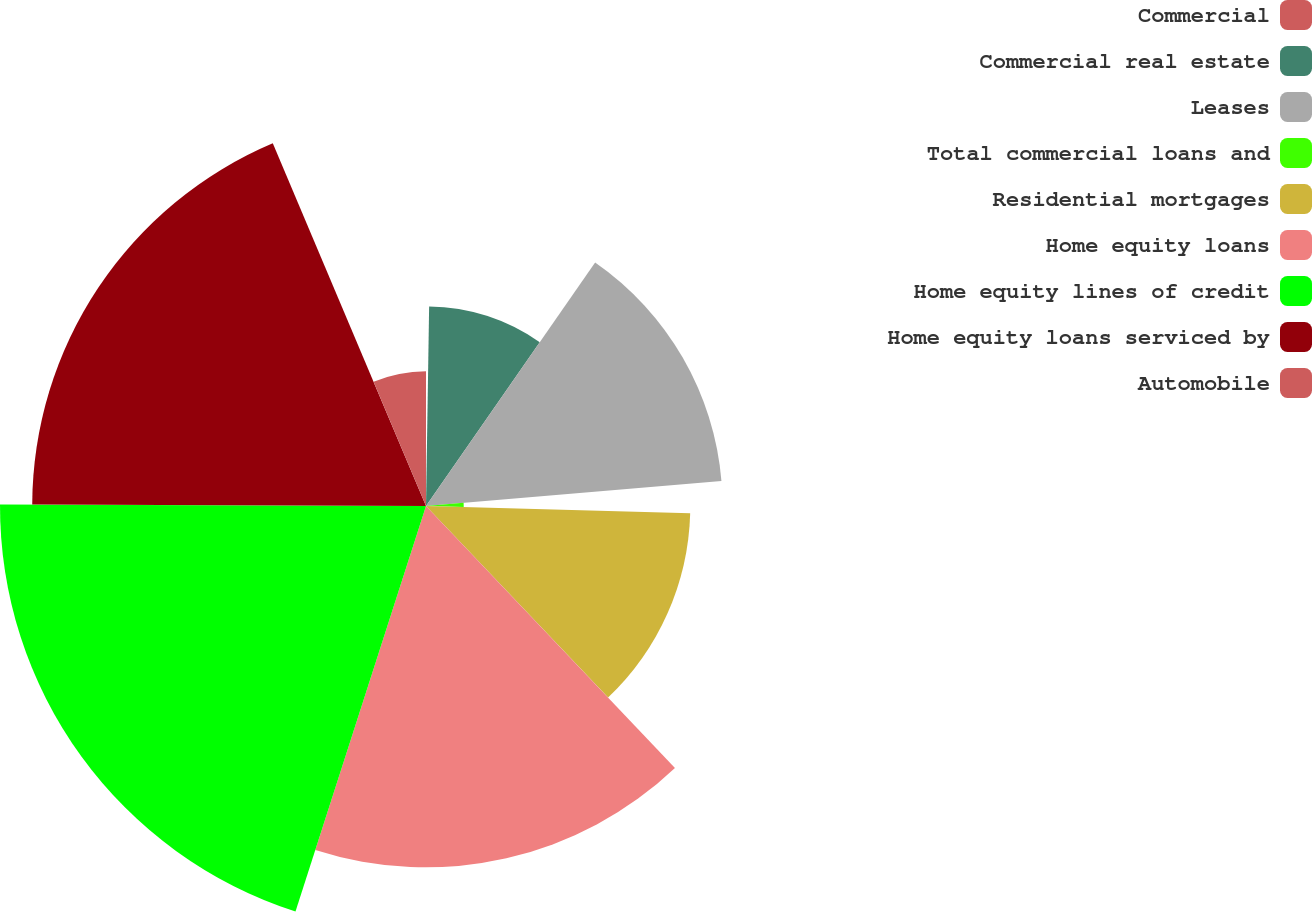<chart> <loc_0><loc_0><loc_500><loc_500><pie_chart><fcel>Commercial<fcel>Commercial real estate<fcel>Leases<fcel>Total commercial loans and<fcel>Residential mortgages<fcel>Home equity loans<fcel>Home equity lines of credit<fcel>Home equity loans serviced by<fcel>Automobile<nl><fcel>0.25%<fcel>9.41%<fcel>13.99%<fcel>1.78%<fcel>12.47%<fcel>17.05%<fcel>20.1%<fcel>18.58%<fcel>6.36%<nl></chart> 